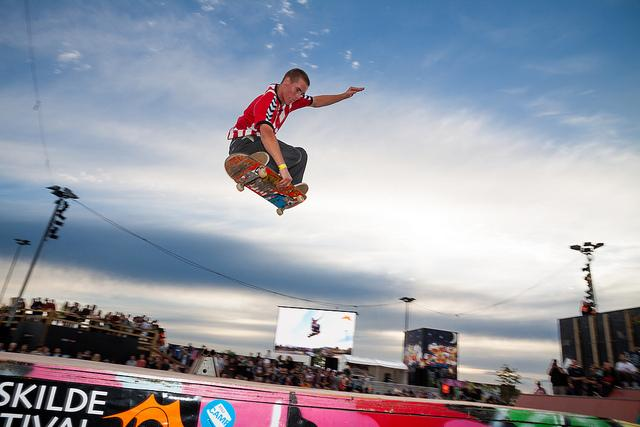What is the name of the trick the man in red is performing? Please explain your reasoning. grab. He is holding on to his board as he is in the air. 